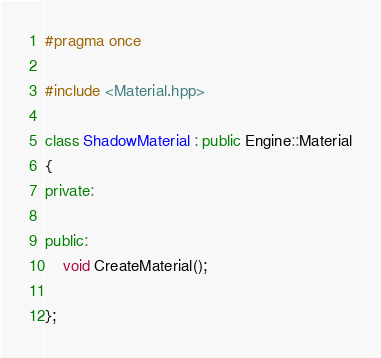Convert code to text. <code><loc_0><loc_0><loc_500><loc_500><_C++_>#pragma once

#include <Material.hpp>

class ShadowMaterial : public Engine::Material
{
private:
    
public:
    void CreateMaterial();
	
};
</code> 